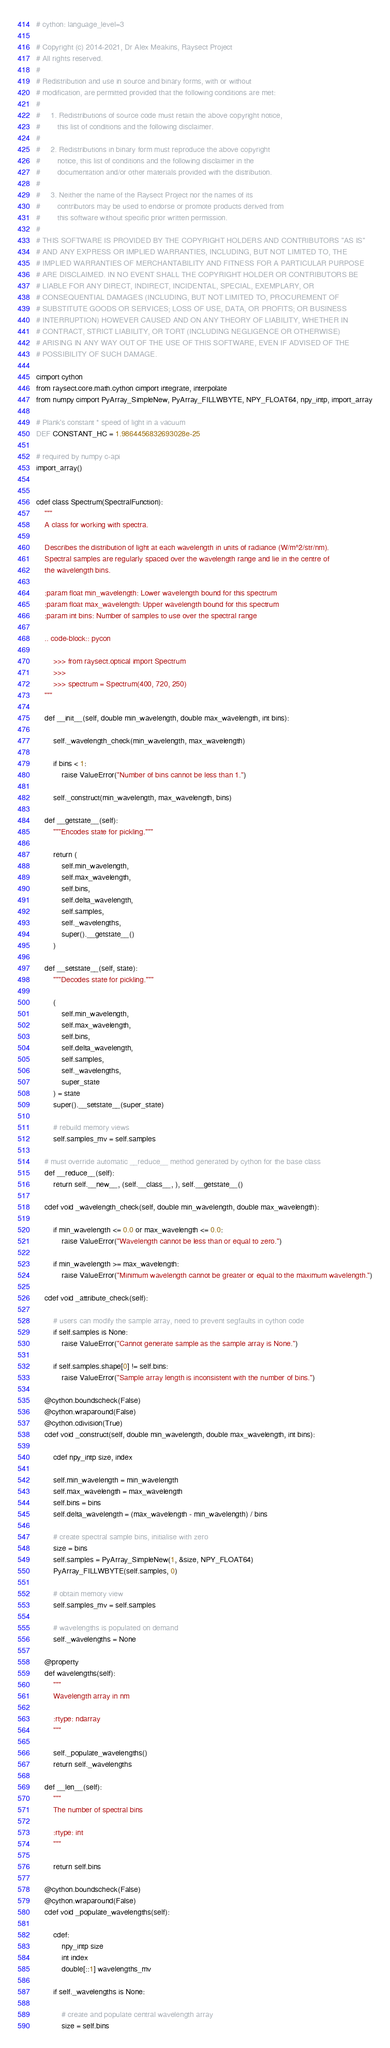Convert code to text. <code><loc_0><loc_0><loc_500><loc_500><_Cython_># cython: language_level=3

# Copyright (c) 2014-2021, Dr Alex Meakins, Raysect Project
# All rights reserved.
#
# Redistribution and use in source and binary forms, with or without
# modification, are permitted provided that the following conditions are met:
#
#     1. Redistributions of source code must retain the above copyright notice,
#        this list of conditions and the following disclaimer.
#
#     2. Redistributions in binary form must reproduce the above copyright
#        notice, this list of conditions and the following disclaimer in the
#        documentation and/or other materials provided with the distribution.
#
#     3. Neither the name of the Raysect Project nor the names of its
#        contributors may be used to endorse or promote products derived from
#        this software without specific prior written permission.
#
# THIS SOFTWARE IS PROVIDED BY THE COPYRIGHT HOLDERS AND CONTRIBUTORS "AS IS"
# AND ANY EXPRESS OR IMPLIED WARRANTIES, INCLUDING, BUT NOT LIMITED TO, THE
# IMPLIED WARRANTIES OF MERCHANTABILITY AND FITNESS FOR A PARTICULAR PURPOSE
# ARE DISCLAIMED. IN NO EVENT SHALL THE COPYRIGHT HOLDER OR CONTRIBUTORS BE
# LIABLE FOR ANY DIRECT, INDIRECT, INCIDENTAL, SPECIAL, EXEMPLARY, OR
# CONSEQUENTIAL DAMAGES (INCLUDING, BUT NOT LIMITED TO, PROCUREMENT OF
# SUBSTITUTE GOODS OR SERVICES; LOSS OF USE, DATA, OR PROFITS; OR BUSINESS
# INTERRUPTION) HOWEVER CAUSED AND ON ANY THEORY OF LIABILITY, WHETHER IN
# CONTRACT, STRICT LIABILITY, OR TORT (INCLUDING NEGLIGENCE OR OTHERWISE)
# ARISING IN ANY WAY OUT OF THE USE OF THIS SOFTWARE, EVEN IF ADVISED OF THE
# POSSIBILITY OF SUCH DAMAGE.

cimport cython
from raysect.core.math.cython cimport integrate, interpolate
from numpy cimport PyArray_SimpleNew, PyArray_FILLWBYTE, NPY_FLOAT64, npy_intp, import_array

# Plank's constant * speed of light in a vacuum
DEF CONSTANT_HC = 1.9864456832693028e-25

# required by numpy c-api
import_array()


cdef class Spectrum(SpectralFunction):
    """
    A class for working with spectra.

    Describes the distribution of light at each wavelength in units of radiance (W/m^2/str/nm).
    Spectral samples are regularly spaced over the wavelength range and lie in the centre of
    the wavelength bins.

    :param float min_wavelength: Lower wavelength bound for this spectrum
    :param float max_wavelength: Upper wavelength bound for this spectrum
    :param int bins: Number of samples to use over the spectral range

    .. code-block:: pycon

        >>> from raysect.optical import Spectrum
        >>>
        >>> spectrum = Spectrum(400, 720, 250)
    """

    def __init__(self, double min_wavelength, double max_wavelength, int bins):

        self._wavelength_check(min_wavelength, max_wavelength)

        if bins < 1:
            raise ValueError("Number of bins cannot be less than 1.")

        self._construct(min_wavelength, max_wavelength, bins)

    def __getstate__(self):
        """Encodes state for pickling."""

        return (
            self.min_wavelength,
            self.max_wavelength,
            self.bins,
            self.delta_wavelength,
            self.samples,
            self._wavelengths,
            super().__getstate__()
        )

    def __setstate__(self, state):
        """Decodes state for pickling."""

        (
            self.min_wavelength,
            self.max_wavelength,
            self.bins,
            self.delta_wavelength,
            self.samples,
            self._wavelengths,
            super_state
        ) = state
        super().__setstate__(super_state)

        # rebuild memory views
        self.samples_mv = self.samples

    # must override automatic __reduce__ method generated by cython for the base class
    def __reduce__(self):
        return self.__new__, (self.__class__, ), self.__getstate__()

    cdef void _wavelength_check(self, double min_wavelength, double max_wavelength):

        if min_wavelength <= 0.0 or max_wavelength <= 0.0:
            raise ValueError("Wavelength cannot be less than or equal to zero.")

        if min_wavelength >= max_wavelength:
            raise ValueError("Minimum wavelength cannot be greater or equal to the maximum wavelength.")

    cdef void _attribute_check(self):

        # users can modify the sample array, need to prevent segfaults in cython code
        if self.samples is None:
            raise ValueError("Cannot generate sample as the sample array is None.")

        if self.samples.shape[0] != self.bins:
            raise ValueError("Sample array length is inconsistent with the number of bins.")

    @cython.boundscheck(False)
    @cython.wraparound(False)
    @cython.cdivision(True)
    cdef void _construct(self, double min_wavelength, double max_wavelength, int bins):

        cdef npy_intp size, index

        self.min_wavelength = min_wavelength
        self.max_wavelength = max_wavelength
        self.bins = bins
        self.delta_wavelength = (max_wavelength - min_wavelength) / bins

        # create spectral sample bins, initialise with zero
        size = bins
        self.samples = PyArray_SimpleNew(1, &size, NPY_FLOAT64)
        PyArray_FILLWBYTE(self.samples, 0)

        # obtain memory view
        self.samples_mv = self.samples

        # wavelengths is populated on demand
        self._wavelengths = None

    @property
    def wavelengths(self):
        """
        Wavelength array in nm

        :rtype: ndarray
        """

        self._populate_wavelengths()
        return self._wavelengths

    def __len__(self):
        """
        The number of spectral bins

        :rtype: int
        """

        return self.bins

    @cython.boundscheck(False)
    @cython.wraparound(False)
    cdef void _populate_wavelengths(self):

        cdef:
            npy_intp size
            int index
            double[::1] wavelengths_mv

        if self._wavelengths is None:

            # create and populate central wavelength array
            size = self.bins</code> 